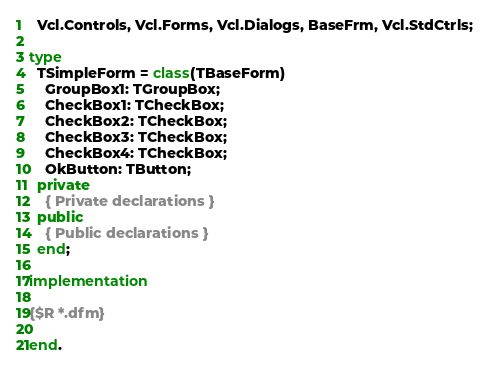<code> <loc_0><loc_0><loc_500><loc_500><_Pascal_>  Vcl.Controls, Vcl.Forms, Vcl.Dialogs, BaseFrm, Vcl.StdCtrls;

type
  TSimpleForm = class(TBaseForm)
    GroupBox1: TGroupBox;
    CheckBox1: TCheckBox;
    CheckBox2: TCheckBox;
    CheckBox3: TCheckBox;
    CheckBox4: TCheckBox;
    OkButton: TButton;
  private
    { Private declarations }
  public
    { Public declarations }
  end;

implementation

{$R *.dfm}

end.
</code> 